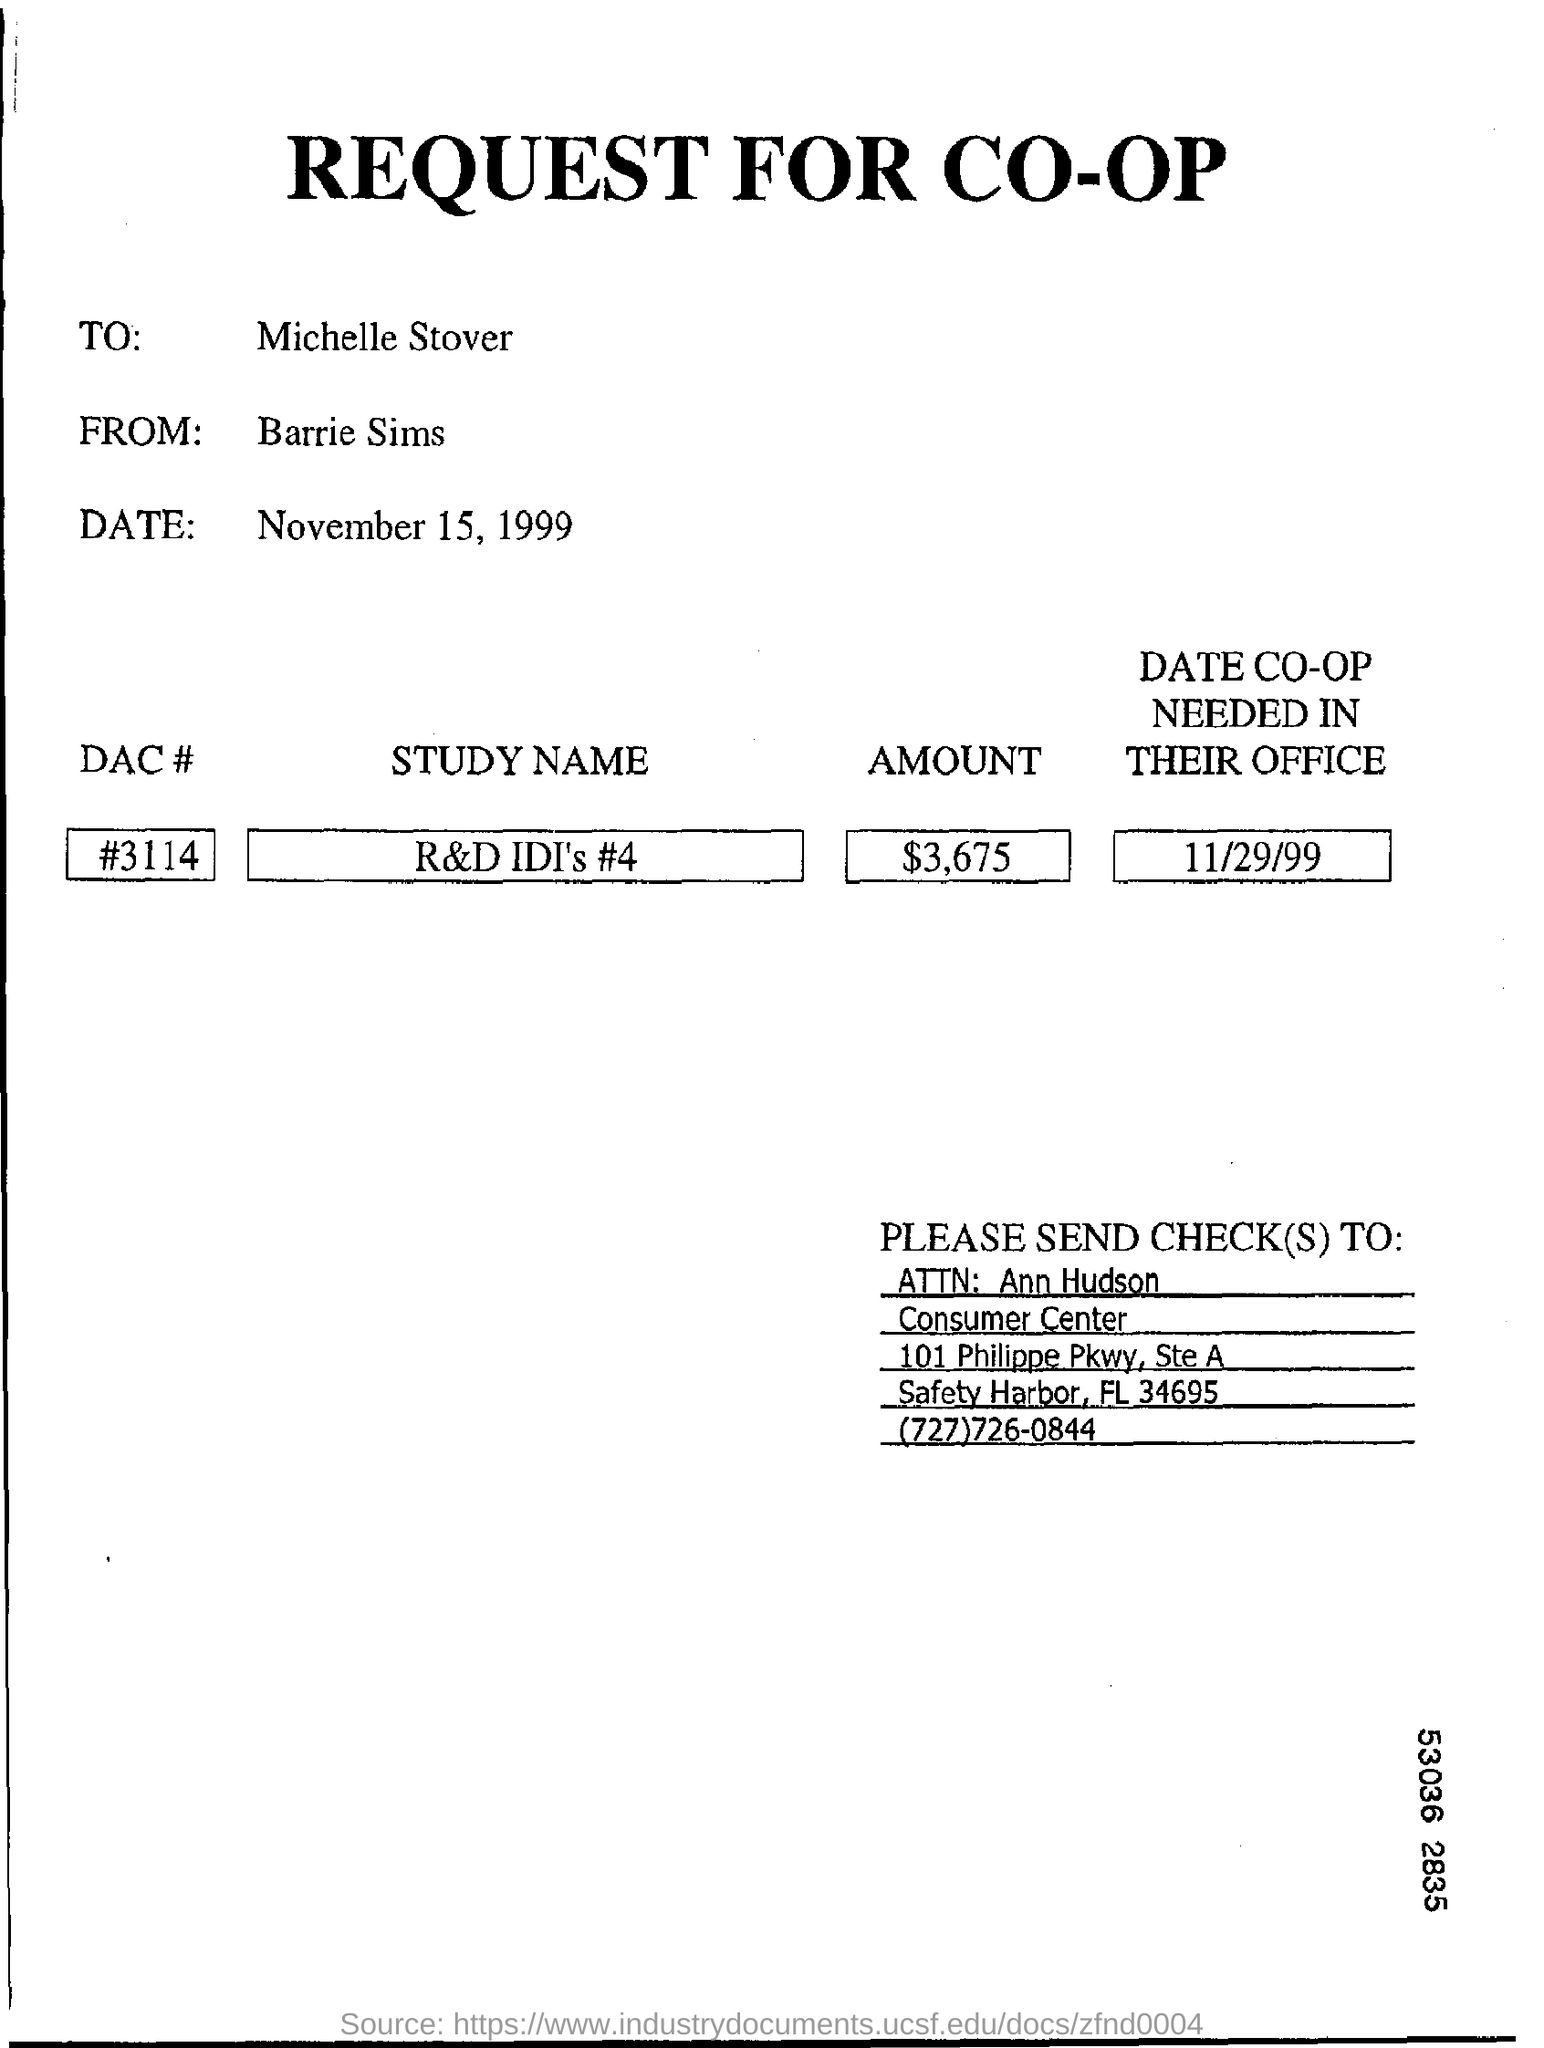Who sends the request?
Offer a very short reply. Barrie Sims. What is the DAC #?
Provide a short and direct response. #3114. What is the date co-op needed in the office?
Your answer should be very brief. 11/29/99. 